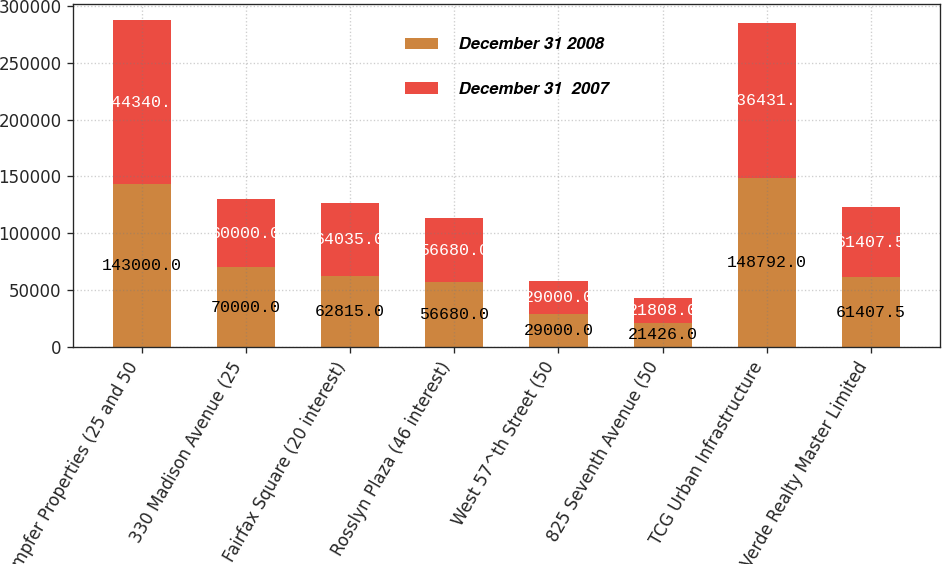<chart> <loc_0><loc_0><loc_500><loc_500><stacked_bar_chart><ecel><fcel>Kaempfer Properties (25 and 50<fcel>330 Madison Avenue (25<fcel>Fairfax Square (20 interest)<fcel>Rosslyn Plaza (46 interest)<fcel>West 57^th Street (50<fcel>825 Seventh Avenue (50<fcel>TCG Urban Infrastructure<fcel>Verde Realty Master Limited<nl><fcel>December 31 2008<fcel>143000<fcel>70000<fcel>62815<fcel>56680<fcel>29000<fcel>21426<fcel>148792<fcel>61407.5<nl><fcel>December 31  2007<fcel>144340<fcel>60000<fcel>64035<fcel>56680<fcel>29000<fcel>21808<fcel>136431<fcel>61407.5<nl></chart> 